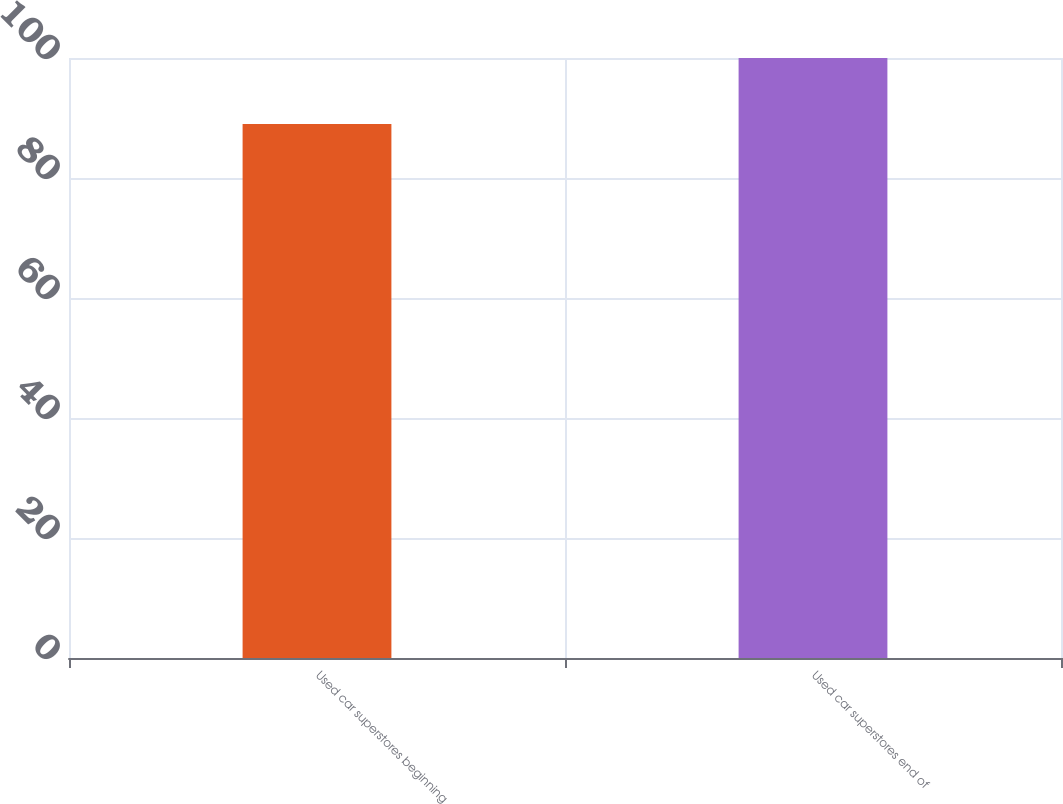Convert chart. <chart><loc_0><loc_0><loc_500><loc_500><bar_chart><fcel>Used car superstores beginning<fcel>Used car superstores end of<nl><fcel>89<fcel>100<nl></chart> 